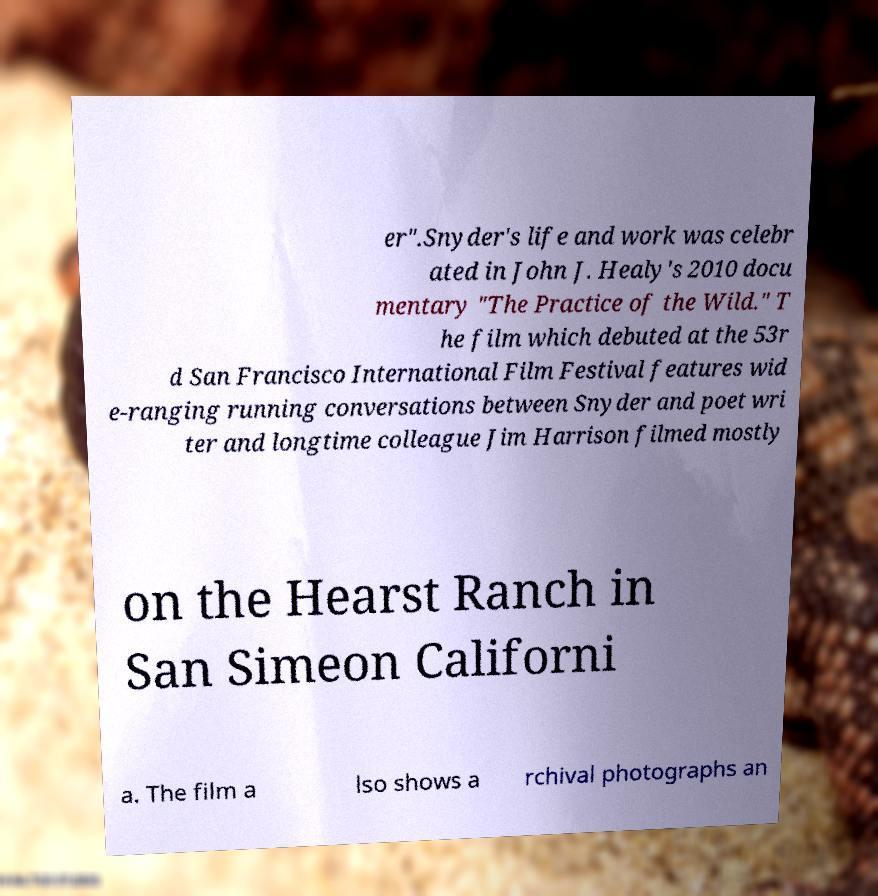Please identify and transcribe the text found in this image. er".Snyder's life and work was celebr ated in John J. Healy's 2010 docu mentary "The Practice of the Wild." T he film which debuted at the 53r d San Francisco International Film Festival features wid e-ranging running conversations between Snyder and poet wri ter and longtime colleague Jim Harrison filmed mostly on the Hearst Ranch in San Simeon Californi a. The film a lso shows a rchival photographs an 